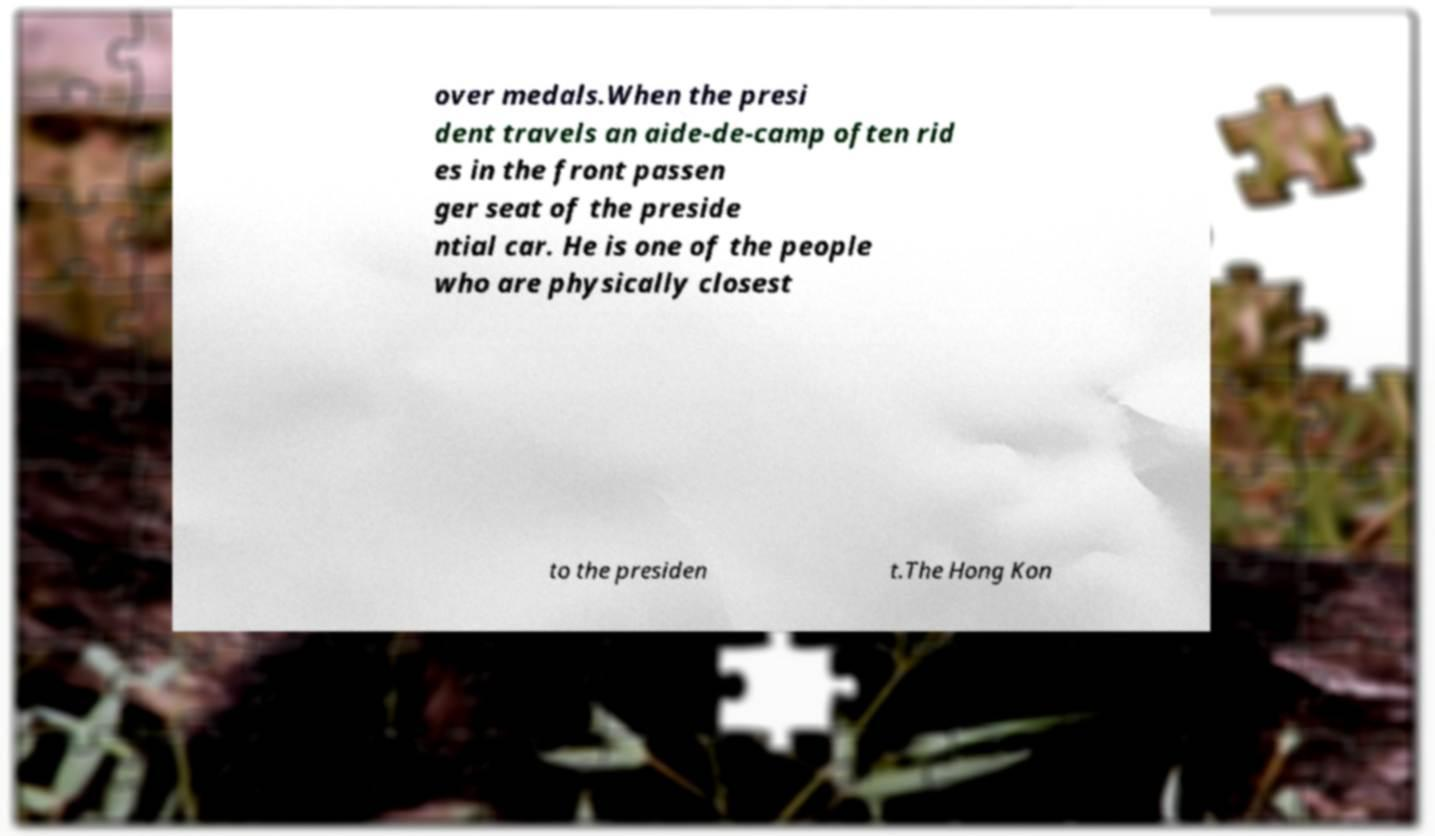Could you assist in decoding the text presented in this image and type it out clearly? over medals.When the presi dent travels an aide-de-camp often rid es in the front passen ger seat of the preside ntial car. He is one of the people who are physically closest to the presiden t.The Hong Kon 